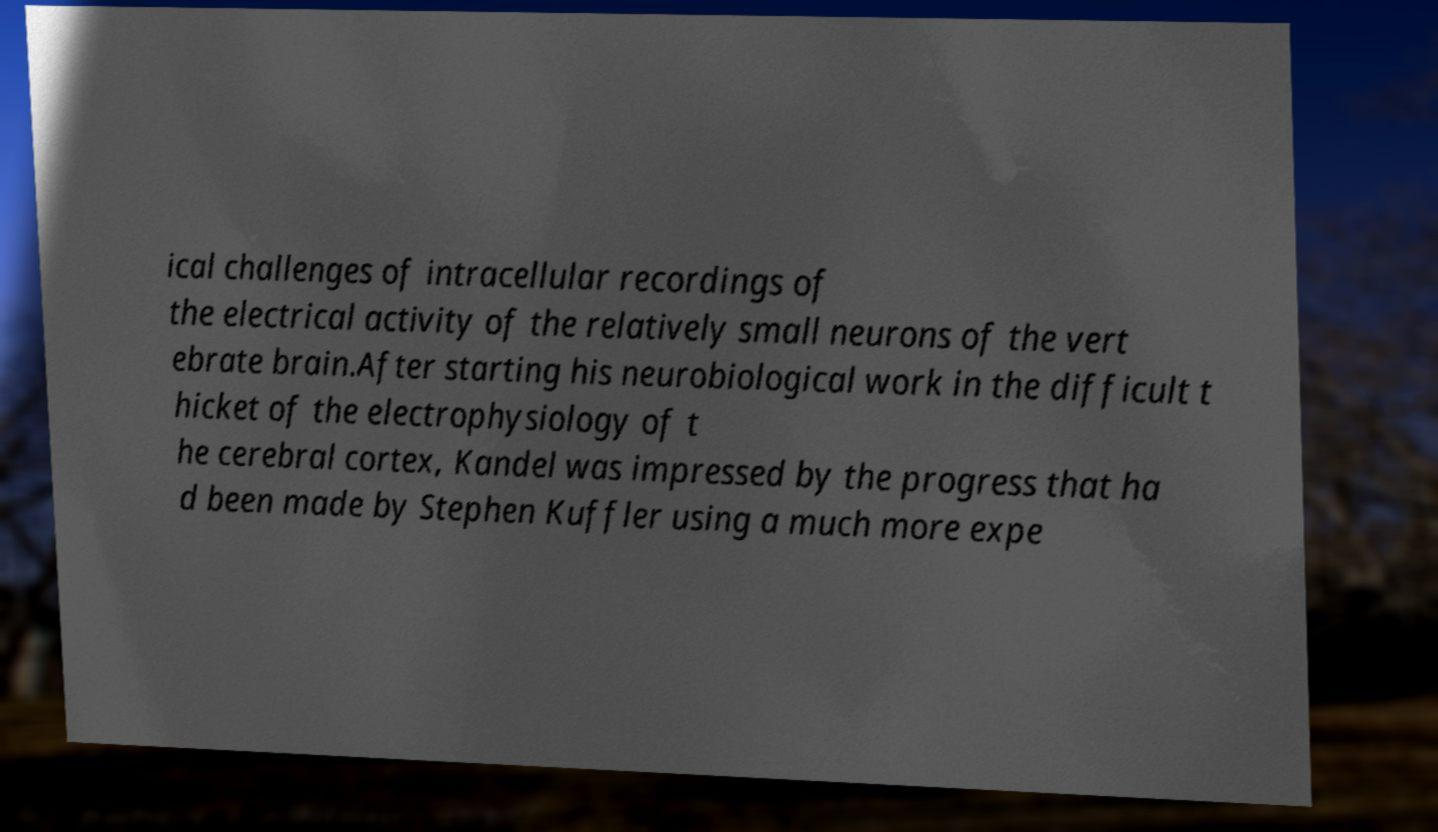There's text embedded in this image that I need extracted. Can you transcribe it verbatim? ical challenges of intracellular recordings of the electrical activity of the relatively small neurons of the vert ebrate brain.After starting his neurobiological work in the difficult t hicket of the electrophysiology of t he cerebral cortex, Kandel was impressed by the progress that ha d been made by Stephen Kuffler using a much more expe 